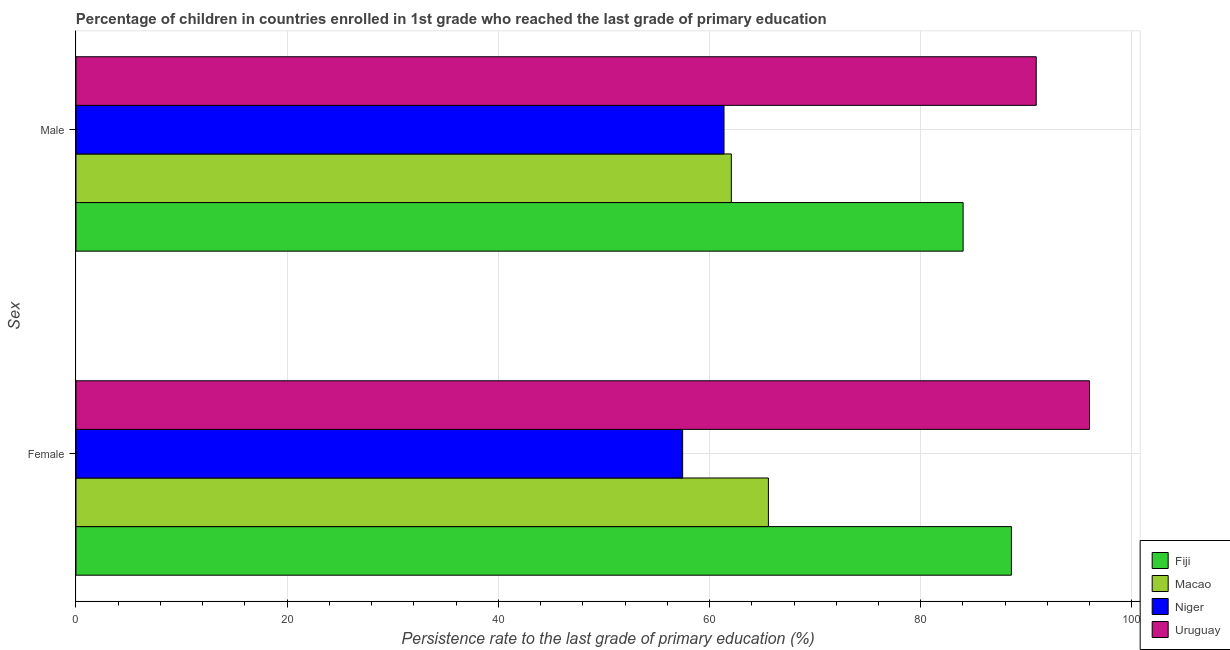How many different coloured bars are there?
Provide a short and direct response. 4. How many groups of bars are there?
Make the answer very short. 2. Are the number of bars per tick equal to the number of legend labels?
Give a very brief answer. Yes. How many bars are there on the 2nd tick from the top?
Make the answer very short. 4. What is the label of the 2nd group of bars from the top?
Make the answer very short. Female. What is the persistence rate of male students in Uruguay?
Keep it short and to the point. 90.94. Across all countries, what is the maximum persistence rate of male students?
Make the answer very short. 90.94. Across all countries, what is the minimum persistence rate of female students?
Your answer should be very brief. 57.45. In which country was the persistence rate of female students maximum?
Provide a short and direct response. Uruguay. In which country was the persistence rate of female students minimum?
Your response must be concise. Niger. What is the total persistence rate of female students in the graph?
Your response must be concise. 307.59. What is the difference between the persistence rate of male students in Uruguay and that in Fiji?
Offer a very short reply. 6.92. What is the difference between the persistence rate of female students in Niger and the persistence rate of male students in Macao?
Offer a terse response. -4.61. What is the average persistence rate of male students per country?
Provide a short and direct response. 74.6. What is the difference between the persistence rate of female students and persistence rate of male students in Uruguay?
Your response must be concise. 5.04. What is the ratio of the persistence rate of male students in Uruguay to that in Fiji?
Provide a succinct answer. 1.08. In how many countries, is the persistence rate of male students greater than the average persistence rate of male students taken over all countries?
Your answer should be very brief. 2. What does the 3rd bar from the top in Male represents?
Your answer should be compact. Macao. What does the 4th bar from the bottom in Male represents?
Offer a very short reply. Uruguay. Are the values on the major ticks of X-axis written in scientific E-notation?
Offer a very short reply. No. Does the graph contain any zero values?
Provide a succinct answer. No. Where does the legend appear in the graph?
Provide a succinct answer. Bottom right. How many legend labels are there?
Your answer should be very brief. 4. What is the title of the graph?
Offer a very short reply. Percentage of children in countries enrolled in 1st grade who reached the last grade of primary education. Does "Solomon Islands" appear as one of the legend labels in the graph?
Your answer should be compact. No. What is the label or title of the X-axis?
Your answer should be very brief. Persistence rate to the last grade of primary education (%). What is the label or title of the Y-axis?
Your answer should be compact. Sex. What is the Persistence rate to the last grade of primary education (%) of Fiji in Female?
Offer a very short reply. 88.59. What is the Persistence rate to the last grade of primary education (%) of Macao in Female?
Your response must be concise. 65.57. What is the Persistence rate to the last grade of primary education (%) in Niger in Female?
Make the answer very short. 57.45. What is the Persistence rate to the last grade of primary education (%) in Uruguay in Female?
Offer a terse response. 95.98. What is the Persistence rate to the last grade of primary education (%) of Fiji in Male?
Provide a short and direct response. 84.01. What is the Persistence rate to the last grade of primary education (%) of Macao in Male?
Give a very brief answer. 62.06. What is the Persistence rate to the last grade of primary education (%) of Niger in Male?
Provide a succinct answer. 61.37. What is the Persistence rate to the last grade of primary education (%) in Uruguay in Male?
Your answer should be very brief. 90.94. Across all Sex, what is the maximum Persistence rate to the last grade of primary education (%) in Fiji?
Keep it short and to the point. 88.59. Across all Sex, what is the maximum Persistence rate to the last grade of primary education (%) of Macao?
Offer a very short reply. 65.57. Across all Sex, what is the maximum Persistence rate to the last grade of primary education (%) in Niger?
Your answer should be very brief. 61.37. Across all Sex, what is the maximum Persistence rate to the last grade of primary education (%) of Uruguay?
Your answer should be very brief. 95.98. Across all Sex, what is the minimum Persistence rate to the last grade of primary education (%) of Fiji?
Offer a terse response. 84.01. Across all Sex, what is the minimum Persistence rate to the last grade of primary education (%) of Macao?
Offer a terse response. 62.06. Across all Sex, what is the minimum Persistence rate to the last grade of primary education (%) of Niger?
Give a very brief answer. 57.45. Across all Sex, what is the minimum Persistence rate to the last grade of primary education (%) in Uruguay?
Offer a terse response. 90.94. What is the total Persistence rate to the last grade of primary education (%) of Fiji in the graph?
Keep it short and to the point. 172.6. What is the total Persistence rate to the last grade of primary education (%) of Macao in the graph?
Offer a terse response. 127.64. What is the total Persistence rate to the last grade of primary education (%) of Niger in the graph?
Give a very brief answer. 118.82. What is the total Persistence rate to the last grade of primary education (%) of Uruguay in the graph?
Offer a terse response. 186.92. What is the difference between the Persistence rate to the last grade of primary education (%) in Fiji in Female and that in Male?
Your answer should be very brief. 4.57. What is the difference between the Persistence rate to the last grade of primary education (%) in Macao in Female and that in Male?
Ensure brevity in your answer.  3.51. What is the difference between the Persistence rate to the last grade of primary education (%) in Niger in Female and that in Male?
Keep it short and to the point. -3.92. What is the difference between the Persistence rate to the last grade of primary education (%) of Uruguay in Female and that in Male?
Your response must be concise. 5.04. What is the difference between the Persistence rate to the last grade of primary education (%) in Fiji in Female and the Persistence rate to the last grade of primary education (%) in Macao in Male?
Give a very brief answer. 26.52. What is the difference between the Persistence rate to the last grade of primary education (%) of Fiji in Female and the Persistence rate to the last grade of primary education (%) of Niger in Male?
Your answer should be very brief. 27.22. What is the difference between the Persistence rate to the last grade of primary education (%) of Fiji in Female and the Persistence rate to the last grade of primary education (%) of Uruguay in Male?
Make the answer very short. -2.35. What is the difference between the Persistence rate to the last grade of primary education (%) in Macao in Female and the Persistence rate to the last grade of primary education (%) in Niger in Male?
Your answer should be very brief. 4.2. What is the difference between the Persistence rate to the last grade of primary education (%) in Macao in Female and the Persistence rate to the last grade of primary education (%) in Uruguay in Male?
Offer a very short reply. -25.36. What is the difference between the Persistence rate to the last grade of primary education (%) of Niger in Female and the Persistence rate to the last grade of primary education (%) of Uruguay in Male?
Your response must be concise. -33.49. What is the average Persistence rate to the last grade of primary education (%) of Fiji per Sex?
Give a very brief answer. 86.3. What is the average Persistence rate to the last grade of primary education (%) in Macao per Sex?
Your response must be concise. 63.82. What is the average Persistence rate to the last grade of primary education (%) in Niger per Sex?
Offer a very short reply. 59.41. What is the average Persistence rate to the last grade of primary education (%) in Uruguay per Sex?
Provide a short and direct response. 93.46. What is the difference between the Persistence rate to the last grade of primary education (%) in Fiji and Persistence rate to the last grade of primary education (%) in Macao in Female?
Make the answer very short. 23.01. What is the difference between the Persistence rate to the last grade of primary education (%) of Fiji and Persistence rate to the last grade of primary education (%) of Niger in Female?
Offer a very short reply. 31.13. What is the difference between the Persistence rate to the last grade of primary education (%) of Fiji and Persistence rate to the last grade of primary education (%) of Uruguay in Female?
Make the answer very short. -7.39. What is the difference between the Persistence rate to the last grade of primary education (%) in Macao and Persistence rate to the last grade of primary education (%) in Niger in Female?
Provide a short and direct response. 8.12. What is the difference between the Persistence rate to the last grade of primary education (%) of Macao and Persistence rate to the last grade of primary education (%) of Uruguay in Female?
Keep it short and to the point. -30.41. What is the difference between the Persistence rate to the last grade of primary education (%) in Niger and Persistence rate to the last grade of primary education (%) in Uruguay in Female?
Provide a short and direct response. -38.53. What is the difference between the Persistence rate to the last grade of primary education (%) in Fiji and Persistence rate to the last grade of primary education (%) in Macao in Male?
Ensure brevity in your answer.  21.95. What is the difference between the Persistence rate to the last grade of primary education (%) in Fiji and Persistence rate to the last grade of primary education (%) in Niger in Male?
Keep it short and to the point. 22.64. What is the difference between the Persistence rate to the last grade of primary education (%) in Fiji and Persistence rate to the last grade of primary education (%) in Uruguay in Male?
Offer a terse response. -6.92. What is the difference between the Persistence rate to the last grade of primary education (%) in Macao and Persistence rate to the last grade of primary education (%) in Niger in Male?
Make the answer very short. 0.69. What is the difference between the Persistence rate to the last grade of primary education (%) in Macao and Persistence rate to the last grade of primary education (%) in Uruguay in Male?
Provide a succinct answer. -28.88. What is the difference between the Persistence rate to the last grade of primary education (%) in Niger and Persistence rate to the last grade of primary education (%) in Uruguay in Male?
Provide a short and direct response. -29.57. What is the ratio of the Persistence rate to the last grade of primary education (%) in Fiji in Female to that in Male?
Provide a short and direct response. 1.05. What is the ratio of the Persistence rate to the last grade of primary education (%) of Macao in Female to that in Male?
Your response must be concise. 1.06. What is the ratio of the Persistence rate to the last grade of primary education (%) of Niger in Female to that in Male?
Keep it short and to the point. 0.94. What is the ratio of the Persistence rate to the last grade of primary education (%) of Uruguay in Female to that in Male?
Give a very brief answer. 1.06. What is the difference between the highest and the second highest Persistence rate to the last grade of primary education (%) of Fiji?
Make the answer very short. 4.57. What is the difference between the highest and the second highest Persistence rate to the last grade of primary education (%) in Macao?
Your answer should be compact. 3.51. What is the difference between the highest and the second highest Persistence rate to the last grade of primary education (%) of Niger?
Make the answer very short. 3.92. What is the difference between the highest and the second highest Persistence rate to the last grade of primary education (%) of Uruguay?
Provide a short and direct response. 5.04. What is the difference between the highest and the lowest Persistence rate to the last grade of primary education (%) of Fiji?
Give a very brief answer. 4.57. What is the difference between the highest and the lowest Persistence rate to the last grade of primary education (%) in Macao?
Provide a short and direct response. 3.51. What is the difference between the highest and the lowest Persistence rate to the last grade of primary education (%) in Niger?
Your answer should be very brief. 3.92. What is the difference between the highest and the lowest Persistence rate to the last grade of primary education (%) in Uruguay?
Offer a very short reply. 5.04. 